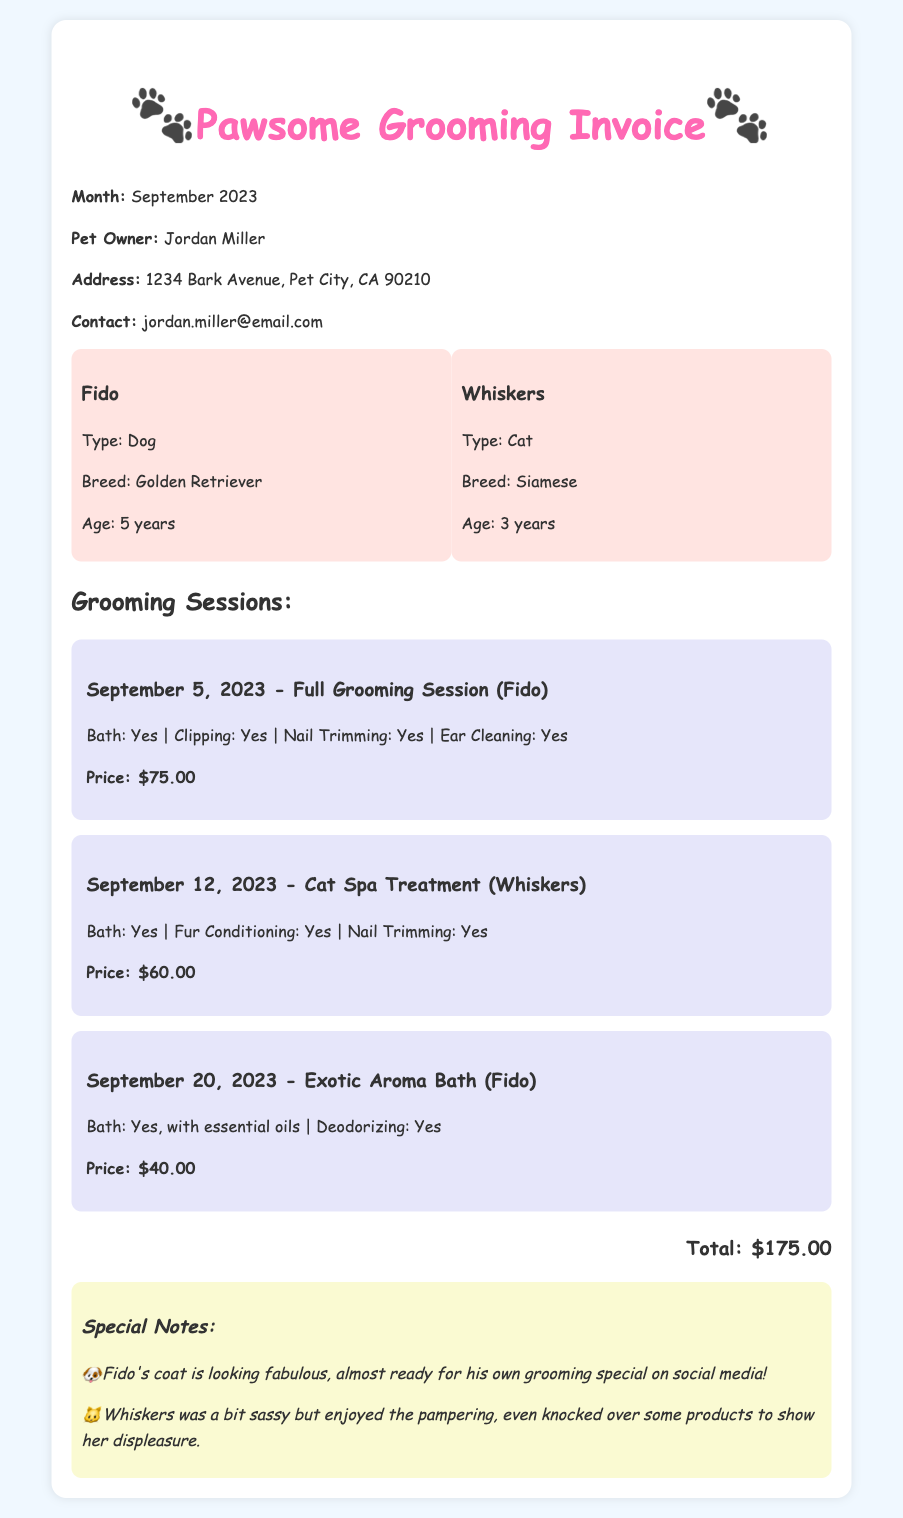What is the total amount due? The total amount due is indicated at the bottom of the invoice, summing all grooming sessions.
Answer: $175.00 How many grooming sessions did Fido receive? The document lists each grooming session, identifying Fido's sessions separately.
Answer: 2 What special treatment did Whiskers receive? A specific grooming session highlights Whiskers’ treatment as "Cat Spa Treatment."
Answer: Cat Spa Treatment On what date did Fido have the Exotic Aroma Bath? The session details include specific dates, with Fido’s Exotic Aroma Bath listed under September 20, 2023.
Answer: September 20, 2023 What was noted about Whiskers' behavior during grooming? Special notes provide insights into Whiskers’ attitude during the pampering session.
Answer: Sassy What grooming service was provided for Fido on September 5, 2023? The grooming session details state the specific services performed on that date.
Answer: Full Grooming Session How much was the price for Whiskers' grooming session? The price is clearly listed next to the details of Whiskers’ grooming session.
Answer: $60.00 What type of pet is Fido? The document specifies the type of Fido as a dog in the pet information section.
Answer: Dog 